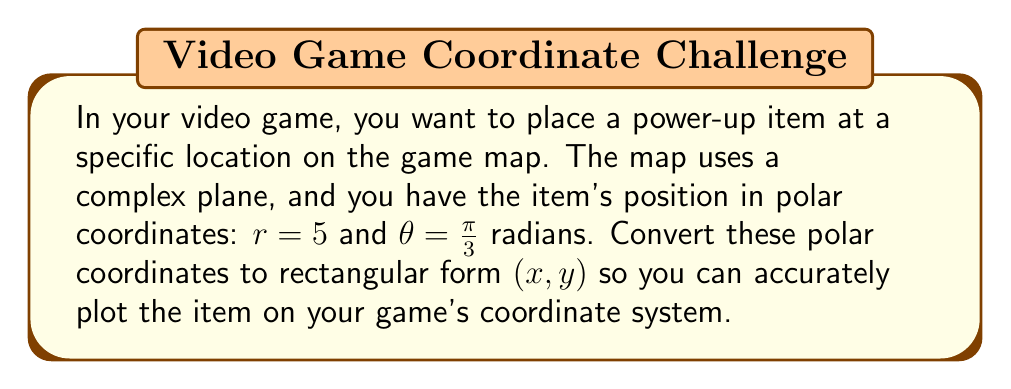Help me with this question. To convert polar coordinates $(r, \theta)$ to rectangular coordinates $(x, y)$, we use the following formulas:

$$x = r \cos(\theta)$$
$$y = r \sin(\theta)$$

Given:
$r = 5$
$\theta = \frac{\pi}{3}$

Step 1: Calculate x
$$x = r \cos(\theta) = 5 \cos(\frac{\pi}{3})$$

$\cos(\frac{\pi}{3}) = \frac{1}{2}$, so:

$$x = 5 \cdot \frac{1}{2} = \frac{5}{2} = 2.5$$

Step 2: Calculate y
$$y = r \sin(\theta) = 5 \sin(\frac{\pi}{3})$$

$\sin(\frac{\pi}{3}) = \frac{\sqrt{3}}{2}$, so:

$$y = 5 \cdot \frac{\sqrt{3}}{2} = \frac{5\sqrt{3}}{2} \approx 4.33$$

Therefore, the rectangular coordinates are $(2.5, \frac{5\sqrt{3}}{2})$ or approximately $(2.5, 4.33)$.
Answer: $(2.5, \frac{5\sqrt{3}}{2})$ or approximately $(2.5, 4.33)$ 